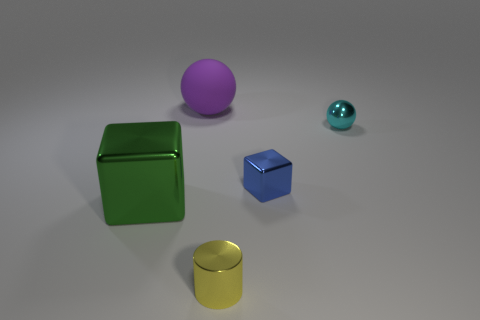Does the block that is right of the large green metallic block have the same color as the block that is left of the matte ball?
Provide a succinct answer. No. What is the shape of the thing that is left of the cylinder and in front of the big purple sphere?
Make the answer very short. Cube. Is there a large blue matte object that has the same shape as the small yellow thing?
Offer a terse response. No. What is the shape of the green shiny thing that is the same size as the purple matte thing?
Your response must be concise. Cube. What is the material of the purple sphere?
Provide a succinct answer. Rubber. There is a sphere that is on the left side of the shiny thing that is behind the shiny cube that is behind the large green metal cube; what is its size?
Your answer should be very brief. Large. What number of metallic things are small things or balls?
Ensure brevity in your answer.  3. The blue shiny block is what size?
Provide a short and direct response. Small. What number of objects are big yellow metal objects or small metal objects to the left of the cyan thing?
Make the answer very short. 2. What number of other things are there of the same color as the large rubber sphere?
Offer a very short reply. 0. 